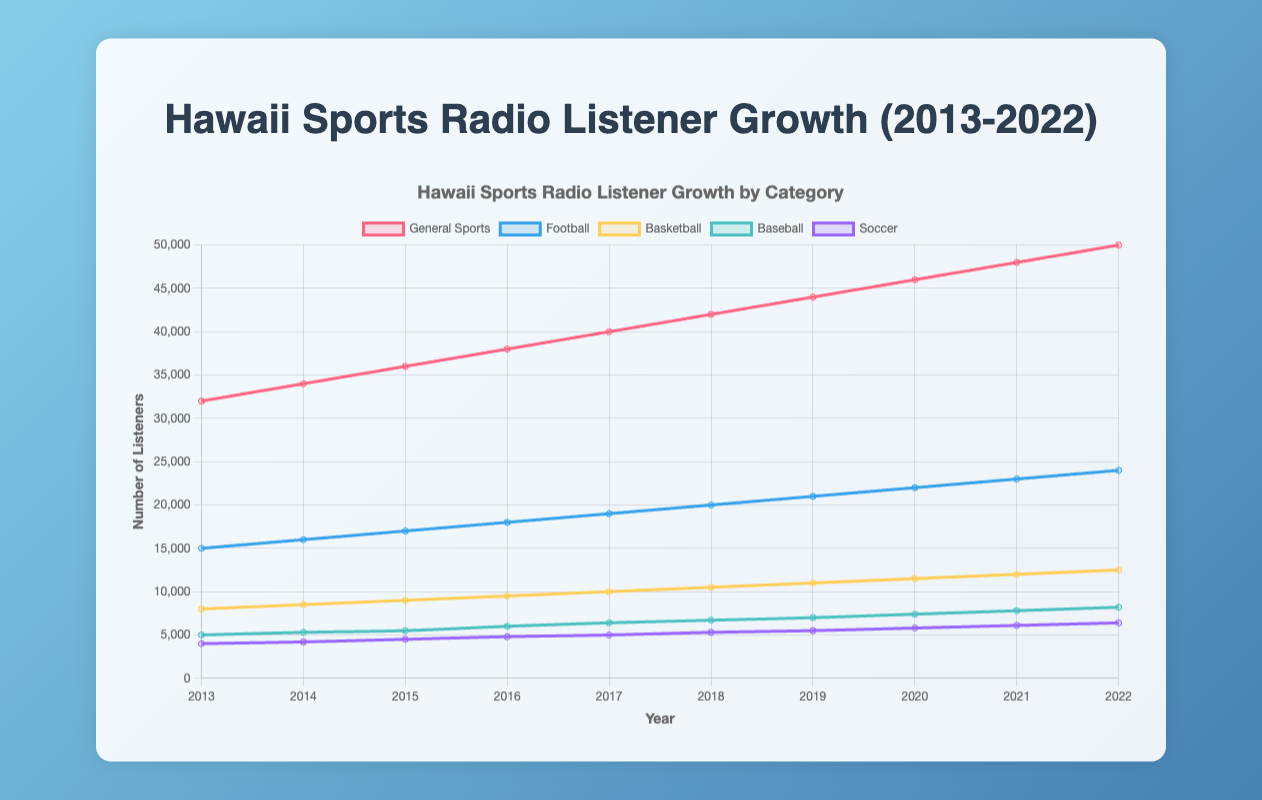How many more general sports listeners were there in 2022 compared to 2013? To find this, subtract the number of general sports listeners in 2013 from the number in 2022. From the data: 50,000 (2022) - 32,000 (2013) = 18,000
Answer: 18,000 Which year saw the highest number of football listeners? By visually identifying the peak point on the football line in the chart, we see that the highest number of football listeners occurred in 2022 with 24,000 listeners.
Answer: 2022 What is the average number of basketball listeners over the decade? Sum the number of basketball listeners for each year, then divide by the number of years (10). From the data: (8,000 + 8,500 + 9,000 + 9,500 + 10,000 + 10,500 + 11,000 + 11,500 + 12,000 + 12,500) / 10 = 103,500 / 10 = 10,350
Answer: 10,350 Did any sports category see a consistent increase in listeners every year from 2013 to 2022? By examining each category's trend line, we see that football listeners increased every single year from 2013 to 2022 without any drops.
Answer: Football Which sports category had the least number of listeners in 2017? Refer to the data for 2017: Soccer had 5,000 listeners, which is the least compared to general sports (40,000), football (19,000), basketball (10,000), and baseball (6,400).
Answer: Soccer How many sports categories exceeded 10,000 listeners in 2016? From the chart data in 2016, general sports (38,000), football (18,000), and basketball (9,500) did not exceed 10,000 listeners, so the only category is general sports which did exceed 10,000 listeners.
Answer: 1 What was the difference in baseball listeners between the years 2018 and 2020? Subtract the number of baseball listeners in 2018 from the number in 2020. From the data: 7,400 (2020) - 6,700 (2018) = 700
Answer: 700 Compare the increment in soccer listeners from 2019 to 2020 with that from 2021 to 2022. Which period saw a greater increase? Calculate the increment for each period: 2020-2019: 5,800 - 5,500 = 300, 2022-2021: 6,400 - 6,100 = 300. Both periods saw the same increase of 300 listeners.
Answer: Both equal (300) What is the trend observed in general sports listeners from 2013 to 2022? By observing the line for general sports listeners, it shows a consistent upward trend, increasing steadily each year from 32,000 in 2013 to 50,000 in 2022.
Answer: Consistent increase 